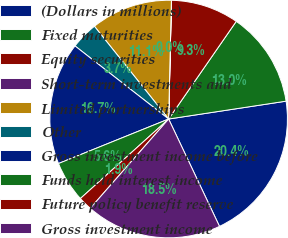Convert chart. <chart><loc_0><loc_0><loc_500><loc_500><pie_chart><fcel>(Dollars in millions)<fcel>Fixed maturities<fcel>Equity securities<fcel>Short-term investments and<fcel>Limited partnerships<fcel>Other<fcel>Gross investment income before<fcel>Funds held interest income<fcel>Future policy benefit reserve<fcel>Gross investment income<nl><fcel>20.36%<fcel>12.96%<fcel>9.26%<fcel>0.01%<fcel>11.11%<fcel>3.71%<fcel>16.66%<fcel>5.56%<fcel>1.86%<fcel>18.51%<nl></chart> 